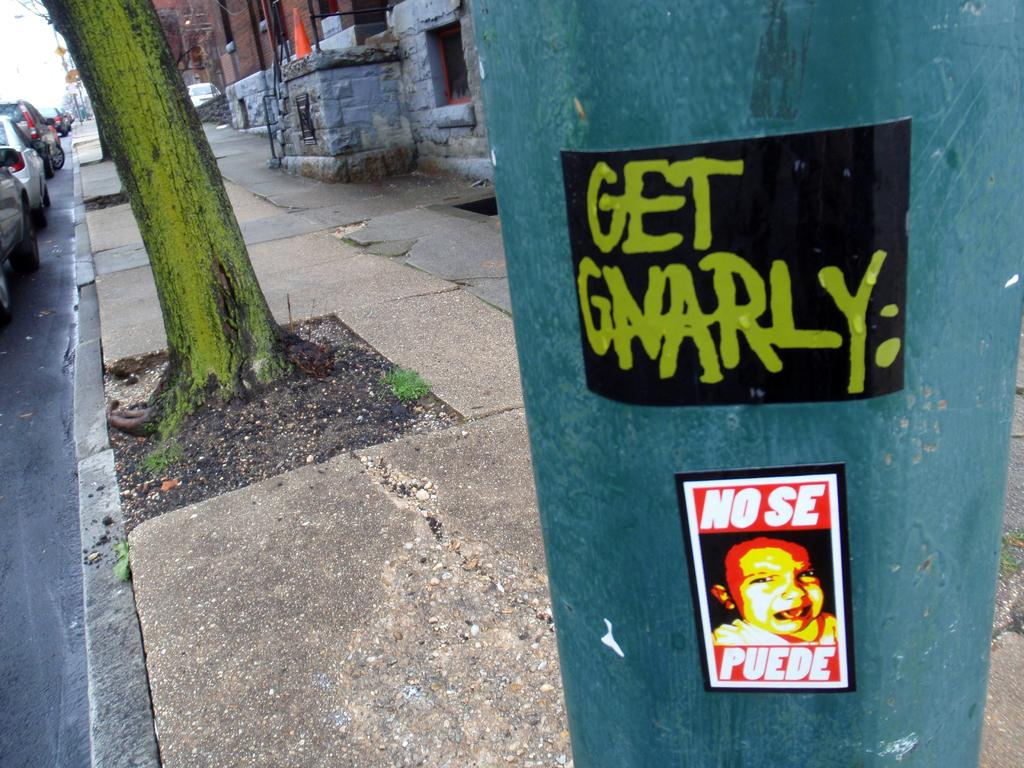<image>
Provide a brief description of the given image. A post with a sign reading Get Gnarly on it. 